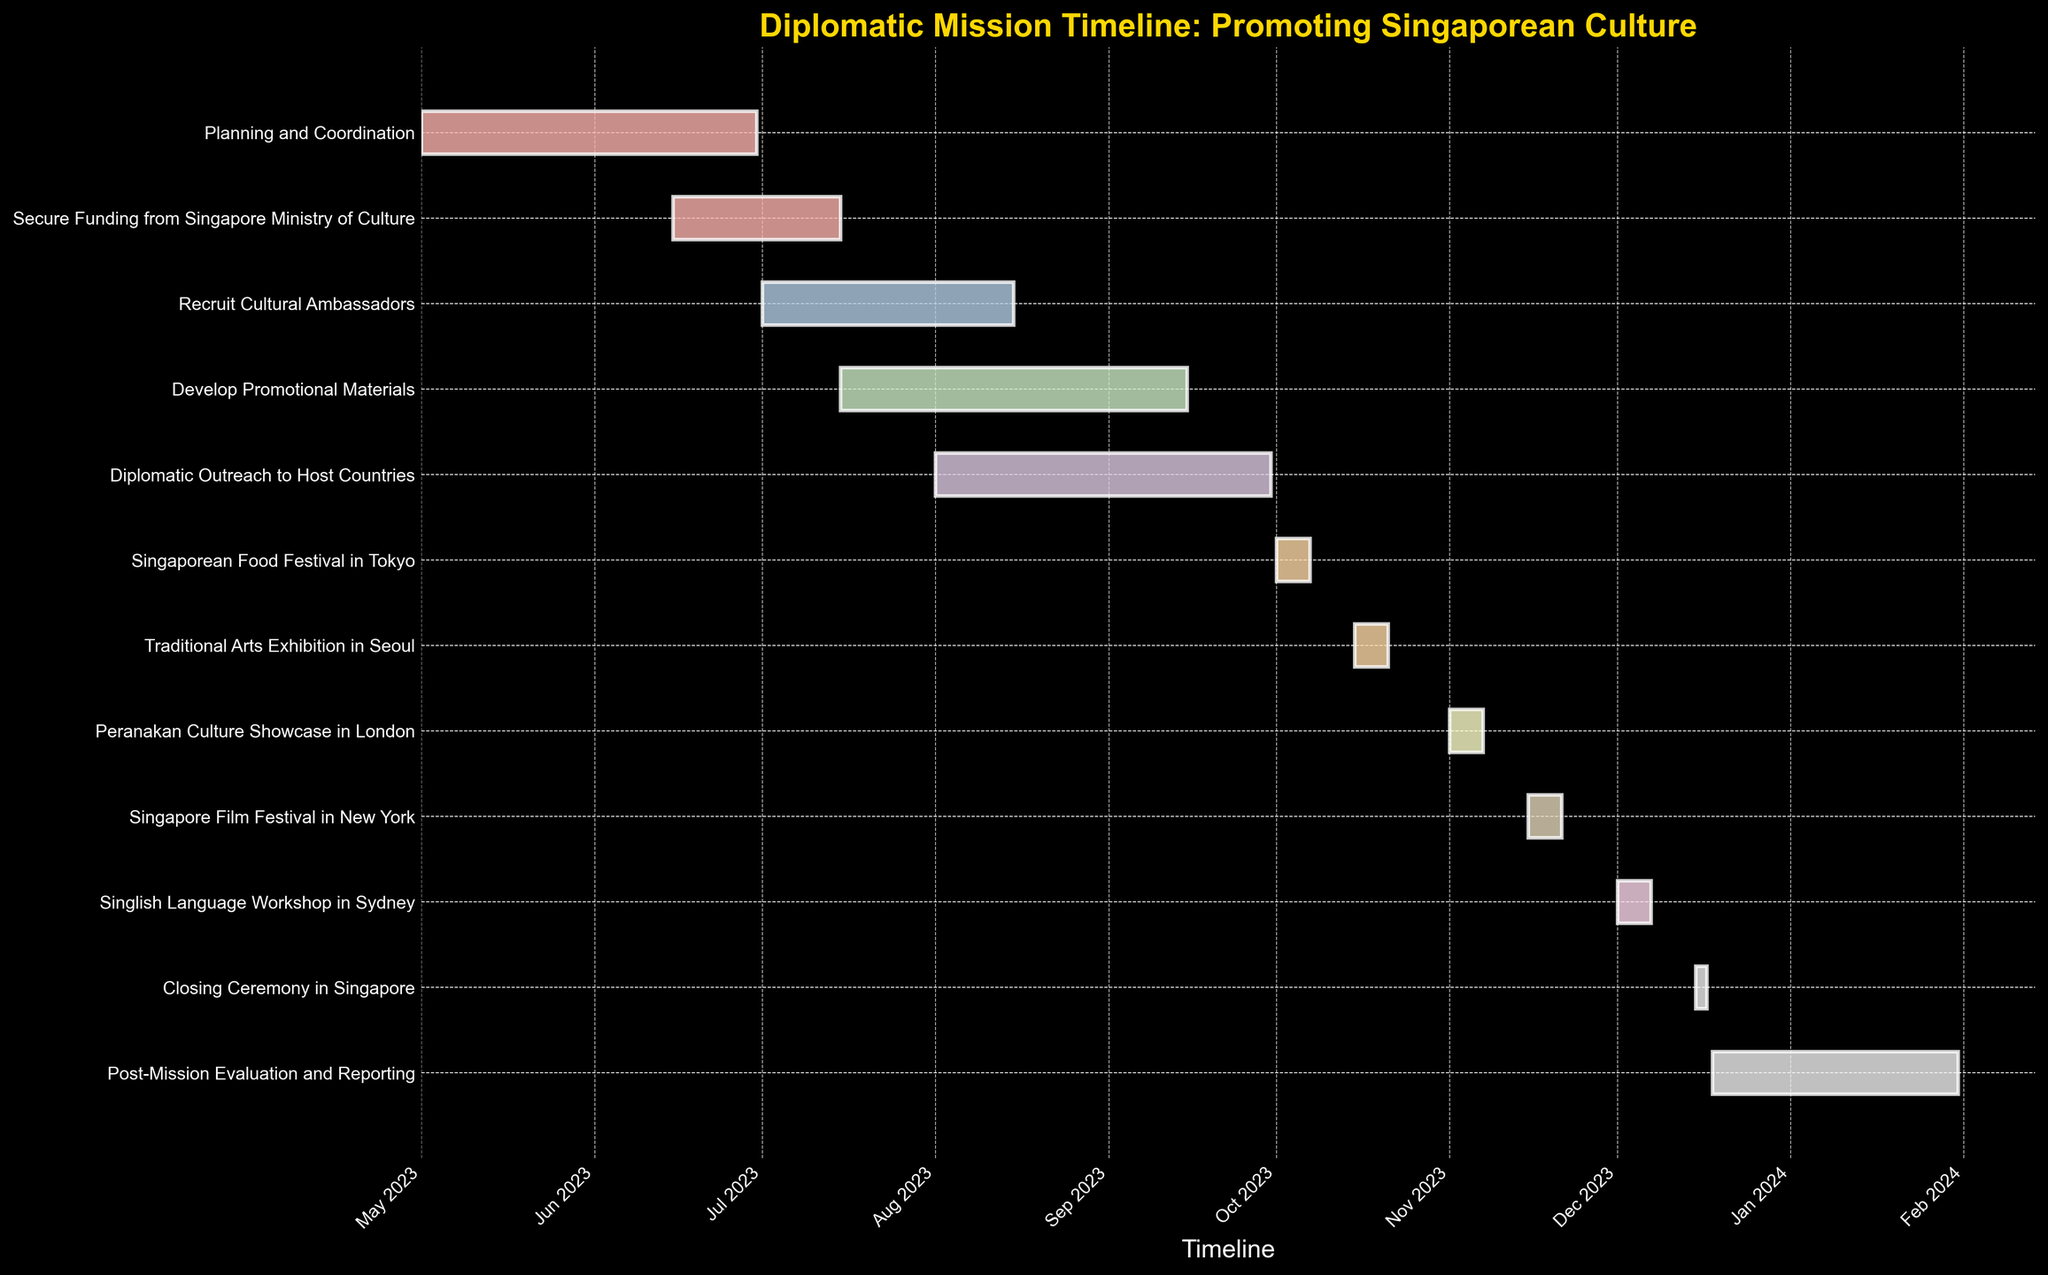What is the title of the Gantt Chart? The title of the Gantt Chart is usually placed at the top of the plot. In this case, the title can be read directly from the plot.
Answer: Diplomatic Mission Timeline: Promoting Singaporean Culture Which task has the shortest duration? To find the shortest duration, examine the lengths of the bars in the Gantt Chart. The one with the smallest horizontal length represents the shortest task.
Answer: Closing Ceremony in Singapore How many tasks are there in total? Count the number of horizontal bars on the Gantt Chart. Each bar represents a task, hence the number of bars equals the number of tasks.
Answer: 11 Which task starts in December? Look for the bar that begins within the December section of the timeline axis at the bottom. Visual cues for December will help identify it.
Answer: Singlish Language Workshop in Sydney What is the time range for the "Recruit Cultural Ambassadors" task? Locate the "Recruit Cultural Ambassadors" bar and note its start and end points. These dates correspond to the task's time range.
Answer: 2023-07-01 to 2023-08-15 Which task overlaps with both "Secure Funding from Singapore Ministry of Culture" and "Develop Promotional Materials"? Identify the tasks mentioned and note their time ranges. Determine if there is another task whose time range intersects with both of these.
Answer: Recruit Cultural Ambassadors What is the total duration of tasks from "Singaporean Food Festival in Tokyo" to "Singapore Film Festival in New York"? Find the start date of "Singaporean Food Festival in Tokyo" and the end date of "Singapore Film Festival in New York", then calculate the duration between these two points.
Answer: 2023-10-01 to 2023-11-21 Which month has the highest number of task start dates? Count the number of tasks that begin in each month by examining the start points of the bars along the timeline. The month with the highest count is the answer.
Answer: October How long is the "Post-Mission Evaluation and Reporting" task? Measure the length of the "Post-Mission Evaluation and Reporting" bar by noting its start and end dates and calculating the duration.
Answer: 45 days 